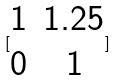Convert formula to latex. <formula><loc_0><loc_0><loc_500><loc_500>[ \begin{matrix} 1 & 1 . 2 5 \\ 0 & 1 \end{matrix} ]</formula> 